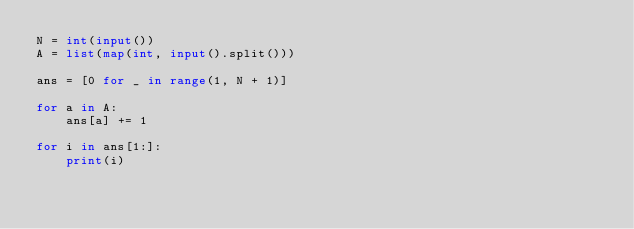Convert code to text. <code><loc_0><loc_0><loc_500><loc_500><_Python_>N = int(input())
A = list(map(int, input().split()))

ans = [0 for _ in range(1, N + 1)]

for a in A:
    ans[a] += 1

for i in ans[1:]:
    print(i)</code> 